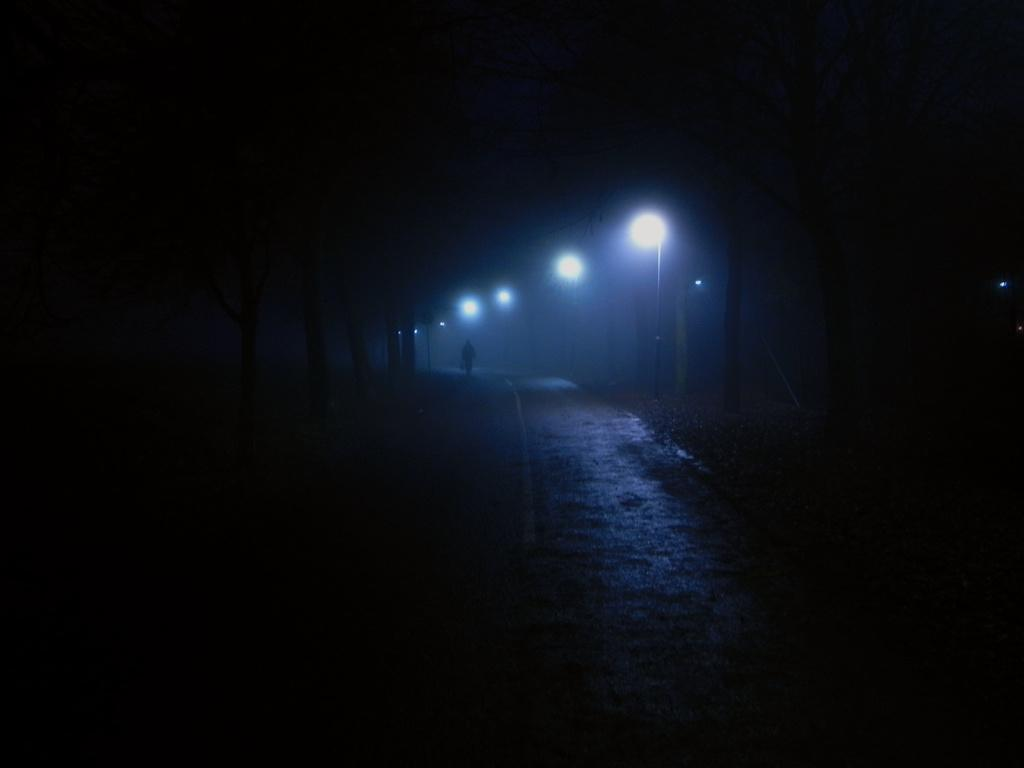What is the overall lighting condition in the image? The image is dark. Can you identify any human presence in the image? Yes, there is a person in the image. What type of pathway is visible in the image? There is a walkway in the image. What provides illumination in the image? Street lights are visible in the image. What structure can be seen in the image that is not related to lighting or pathways? There is a pole in the image. What other object is present in the image that is not related to lighting, pathways, or the pole? A board is present in the image. What type of natural elements can be seen in the image? Trees are present in the image. What type of oil can be seen dripping from the person's hand in the image? There is no oil visible in the image, nor is there any indication that the person's hand is dripping with oil. 